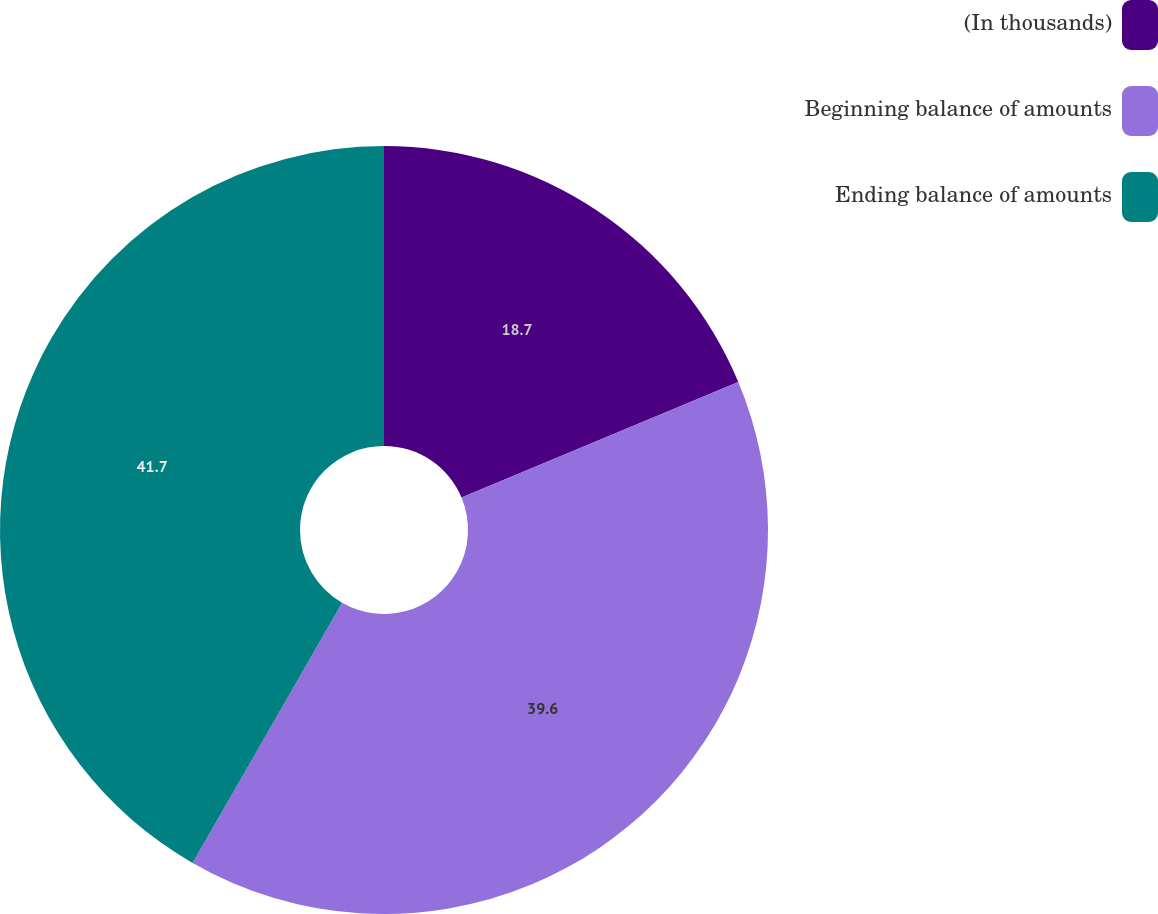Convert chart. <chart><loc_0><loc_0><loc_500><loc_500><pie_chart><fcel>(In thousands)<fcel>Beginning balance of amounts<fcel>Ending balance of amounts<nl><fcel>18.7%<fcel>39.6%<fcel>41.69%<nl></chart> 